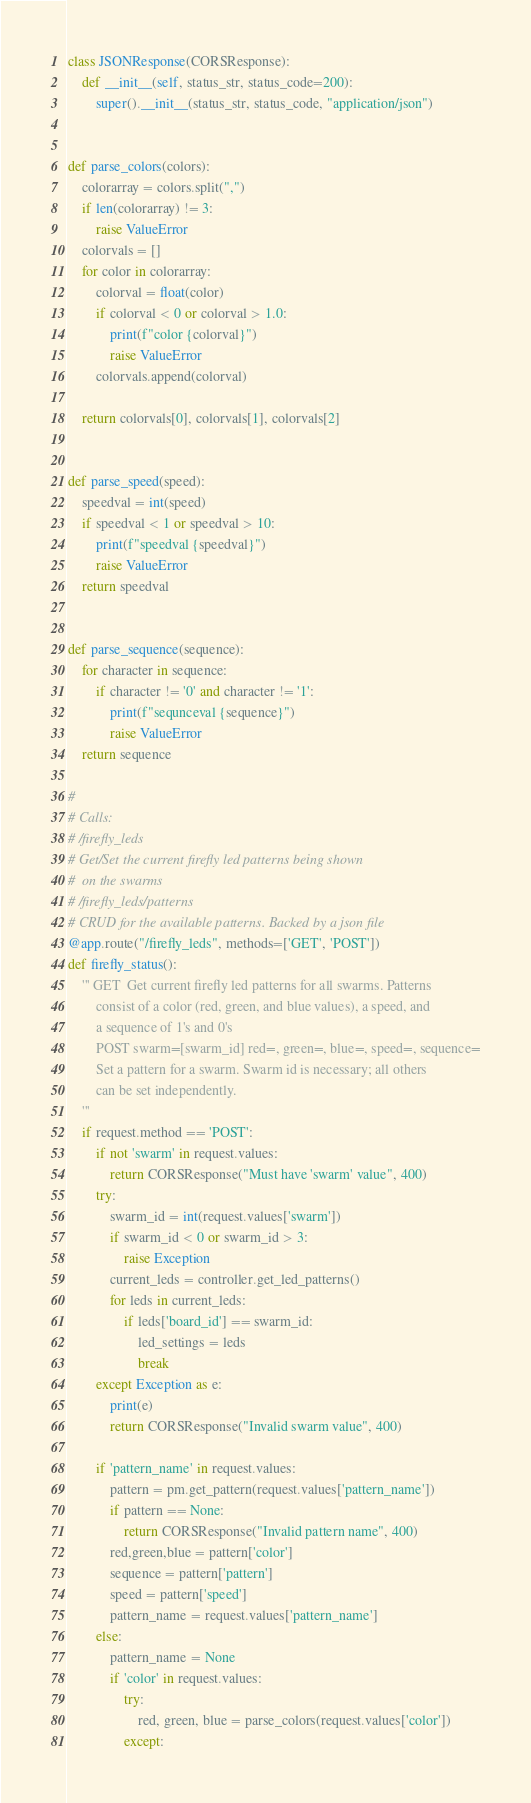<code> <loc_0><loc_0><loc_500><loc_500><_Python_>

class JSONResponse(CORSResponse):
    def __init__(self, status_str, status_code=200):
        super().__init__(status_str, status_code, "application/json")


def parse_colors(colors):
    colorarray = colors.split(",")
    if len(colorarray) != 3:
        raise ValueError
    colorvals = []
    for color in colorarray:
        colorval = float(color)
        if colorval < 0 or colorval > 1.0:
            print(f"color {colorval}")
            raise ValueError
        colorvals.append(colorval)
        
    return colorvals[0], colorvals[1], colorvals[2]


def parse_speed(speed):
    speedval = int(speed)
    if speedval < 1 or speedval > 10:
        print(f"speedval {speedval}")
        raise ValueError
    return speedval


def parse_sequence(sequence):
    for character in sequence:
        if character != '0' and character != '1':
            print(f"sequnceval {sequence}")
            raise ValueError
    return sequence
    
# 
# Calls:
# /firefly_leds 
# Get/Set the current firefly led patterns being shown
#  on the swarms
# /firefly_leds/patterns
# CRUD for the available patterns. Backed by a json file
@app.route("/firefly_leds", methods=['GET', 'POST'])
def firefly_status():
    ''' GET  Get current firefly led patterns for all swarms. Patterns
        consist of a color (red, green, and blue values), a speed, and 
        a sequence of 1's and 0's
        POST swarm=[swarm_id] red=, green=, blue=, speed=, sequence=
        Set a pattern for a swarm. Swarm id is necessary; all others 
        can be set independently.
    '''
    if request.method == 'POST':
        if not 'swarm' in request.values:
            return CORSResponse("Must have 'swarm' value", 400)
        try:
            swarm_id = int(request.values['swarm'])
            if swarm_id < 0 or swarm_id > 3:
                raise Exception
            current_leds = controller.get_led_patterns()
            for leds in current_leds:
                if leds['board_id'] == swarm_id:
                    led_settings = leds
                    break
        except Exception as e:
            print(e)
            return CORSResponse("Invalid swarm value", 400)

        if 'pattern_name' in request.values:
            pattern = pm.get_pattern(request.values['pattern_name'])
            if pattern == None:
                return CORSResponse("Invalid pattern name", 400)
            red,green,blue = pattern['color']
            sequence = pattern['pattern']
            speed = pattern['speed']
            pattern_name = request.values['pattern_name']
        else:
            pattern_name = None  
            if 'color' in request.values:
                try:
                    red, green, blue = parse_colors(request.values['color'])
                except:</code> 